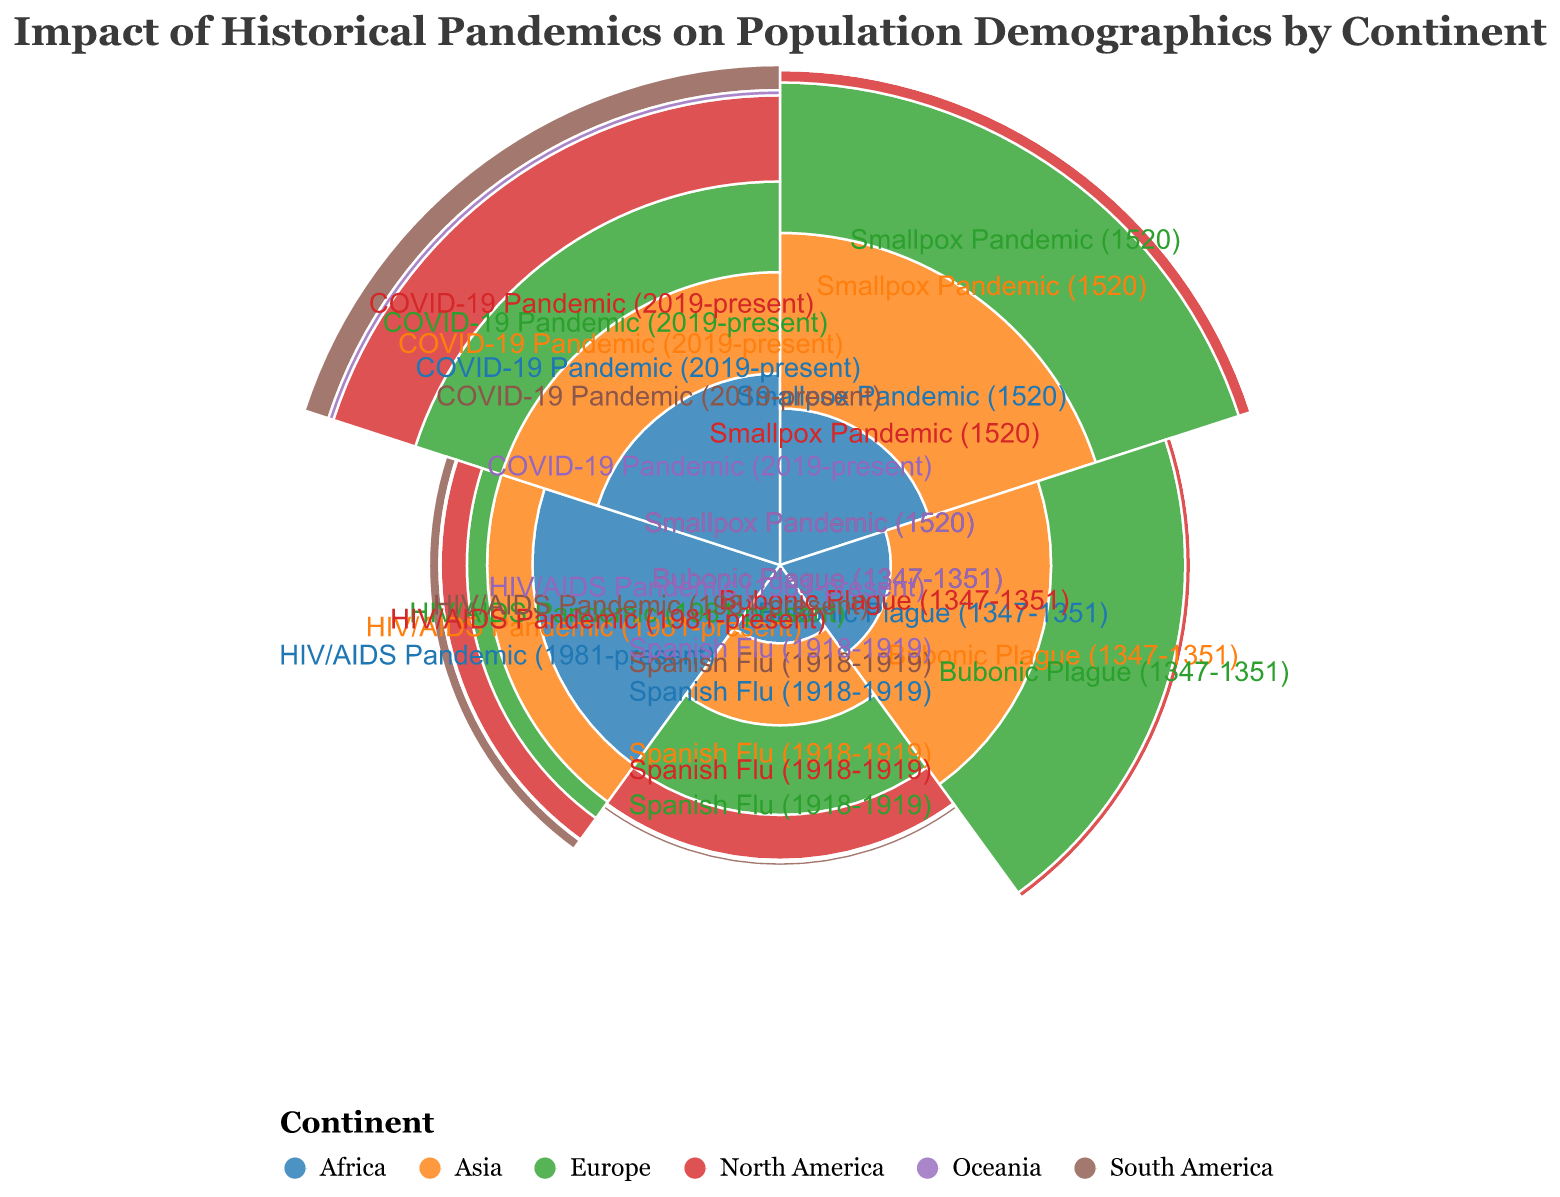What is the highest impact of the Smallpox Pandemic (1520) on any continent? To find the highest impact, look at the data points for the Smallpox Pandemic on each continent. According to the dataset, Europe has the highest impact with 50.
Answer: 50 Which continent had the highest impact due to the Spanish Flu (1918-1919)? To determine the continent with the highest impact, compare the impact values for the Spanish Flu across all continents. Europe records the highest impact at 15.
Answer: Europe Compare the impact of the COVID-19 Pandemic (2019-present) in Africa and North America. Looking at the data for the COVID-19 Pandemic, Africa has an impact of 15, while North America has an impact of 30. North America has a higher impact.
Answer: North America What is the average impact of the Bubonic Plague (1347-1351) on the listed continents? Add up all the impact values for the Bubonic Plague on all continents (5 + 25 + 37 + 2 + 0 + 0) and then divide by the number of continents (6). The total is 69; dividing by 6 gives an average of 11.5.
Answer: 11.5 Which pandemics are documented in South America? Identify the pandemics with non-zero impacts in South America. According to the data, these are the Spanish Flu, HIV/AIDS Pandemic, and COVID-19 Pandemic.
Answer: Spanish Flu, HIV/AIDS Pandemic, COVID-19 Pandemic How does the impact of the HIV/AIDS Pandemic in Africa compare to other continents? Africa's impact from the HIV/AIDS Pandemic is 25. Compare this to other continents: Asia 10, Europe 5, North America 7, South America 3, and Oceania 0.3. Africa has the highest impact.
Answer: Africa Which pandemic had the least impact on Oceania? Examine the impact values for all pandemics on Oceania: Smallpox (0), Bubonic Plague (0), Spanish Flu (0.5), HIV/AIDS (0.3), COVID-19 (2). Both Smallpox and Bubonic Plague had the least impact with a value of 0.
Answer: Smallpox, Bubonic Plague What is the combined impact of all pandemics in Asia? Sum the impacts of all pandemics in Asia: Smallpox (35), Bubonic Plague (25), Spanish Flu (8), HIV/AIDS (10), COVID-19 (20). The total combined impact is 98.
Answer: 98 Which continent experienced the smallest total impact from all pandemics? Sum the impacts of all pandemics for each continent. Africa total: 57.5, Asia total: 98, Europe total: 132, North America total: 54, South America total: 14, Oceania total: 2. Oceania has the smallest total impact.
Answer: Oceania What is the difference in impact between the Smallpox Pandemic and COVID-19 Pandemic in Europe? According to the data, the impact of the Smallpox Pandemic in Europe is 50, and the impact of the COVID-19 Pandemic is 25. The difference is 50 - 25 = 25.
Answer: 25 